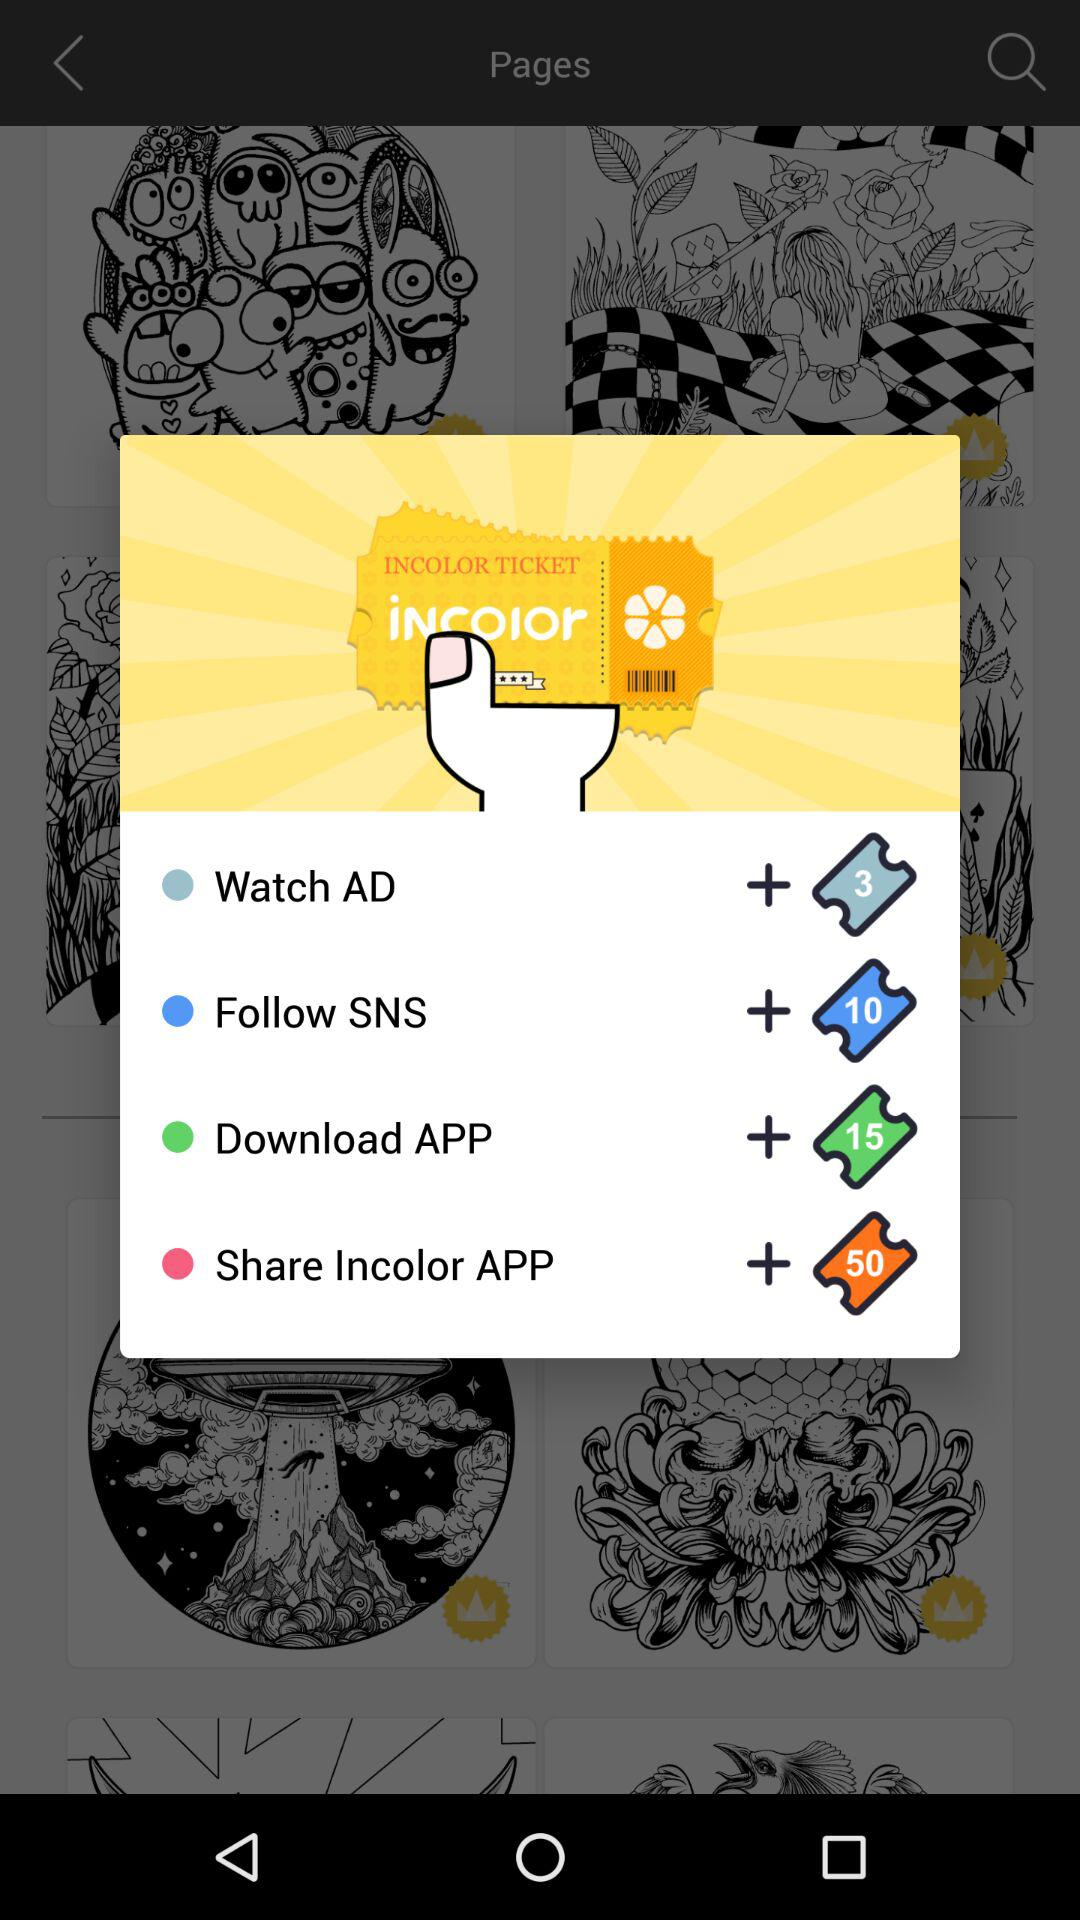How many tickets will be earned by following SNS? By following SNS, 10 tickets will be earned. 